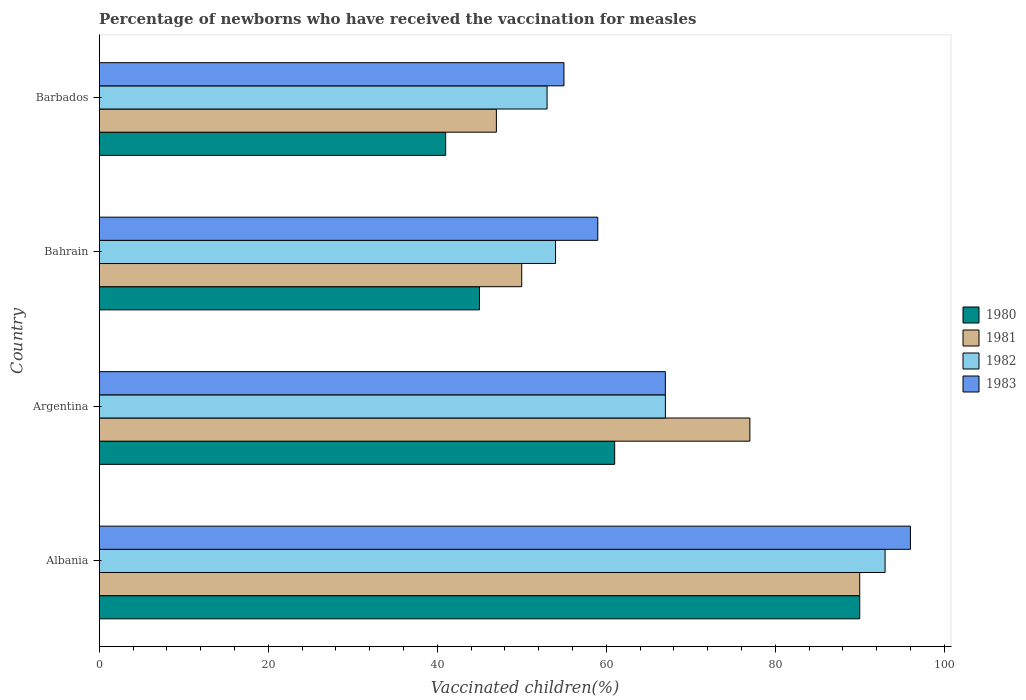How many different coloured bars are there?
Offer a very short reply. 4. Are the number of bars per tick equal to the number of legend labels?
Make the answer very short. Yes. How many bars are there on the 2nd tick from the top?
Provide a short and direct response. 4. How many bars are there on the 3rd tick from the bottom?
Offer a very short reply. 4. What is the label of the 2nd group of bars from the top?
Provide a succinct answer. Bahrain. In how many cases, is the number of bars for a given country not equal to the number of legend labels?
Provide a short and direct response. 0. What is the percentage of vaccinated children in 1983 in Albania?
Your response must be concise. 96. Across all countries, what is the maximum percentage of vaccinated children in 1982?
Your response must be concise. 93. In which country was the percentage of vaccinated children in 1980 maximum?
Give a very brief answer. Albania. In which country was the percentage of vaccinated children in 1980 minimum?
Offer a terse response. Barbados. What is the total percentage of vaccinated children in 1981 in the graph?
Offer a very short reply. 264. What is the difference between the percentage of vaccinated children in 1980 in Argentina and that in Bahrain?
Make the answer very short. 16. What is the difference between the percentage of vaccinated children in 1981 in Albania and the percentage of vaccinated children in 1982 in Bahrain?
Offer a terse response. 36. What is the average percentage of vaccinated children in 1980 per country?
Keep it short and to the point. 59.25. What is the difference between the percentage of vaccinated children in 1982 and percentage of vaccinated children in 1981 in Argentina?
Keep it short and to the point. -10. What is the ratio of the percentage of vaccinated children in 1982 in Albania to that in Argentina?
Keep it short and to the point. 1.39. Is the percentage of vaccinated children in 1981 in Bahrain less than that in Barbados?
Provide a short and direct response. No. Is the difference between the percentage of vaccinated children in 1982 in Albania and Barbados greater than the difference between the percentage of vaccinated children in 1981 in Albania and Barbados?
Make the answer very short. No. What is the difference between the highest and the second highest percentage of vaccinated children in 1981?
Make the answer very short. 13. In how many countries, is the percentage of vaccinated children in 1982 greater than the average percentage of vaccinated children in 1982 taken over all countries?
Give a very brief answer. 2. Is the sum of the percentage of vaccinated children in 1982 in Albania and Barbados greater than the maximum percentage of vaccinated children in 1980 across all countries?
Keep it short and to the point. Yes. What does the 4th bar from the bottom in Bahrain represents?
Your answer should be compact. 1983. Are all the bars in the graph horizontal?
Provide a succinct answer. Yes. How many countries are there in the graph?
Make the answer very short. 4. Does the graph contain any zero values?
Give a very brief answer. No. Where does the legend appear in the graph?
Make the answer very short. Center right. How are the legend labels stacked?
Make the answer very short. Vertical. What is the title of the graph?
Provide a succinct answer. Percentage of newborns who have received the vaccination for measles. Does "2010" appear as one of the legend labels in the graph?
Make the answer very short. No. What is the label or title of the X-axis?
Your response must be concise. Vaccinated children(%). What is the Vaccinated children(%) of 1980 in Albania?
Your response must be concise. 90. What is the Vaccinated children(%) of 1982 in Albania?
Offer a terse response. 93. What is the Vaccinated children(%) in 1983 in Albania?
Provide a short and direct response. 96. What is the Vaccinated children(%) of 1980 in Argentina?
Your answer should be very brief. 61. What is the Vaccinated children(%) of 1981 in Argentina?
Make the answer very short. 77. What is the Vaccinated children(%) in 1982 in Argentina?
Make the answer very short. 67. What is the Vaccinated children(%) of 1983 in Argentina?
Make the answer very short. 67. What is the Vaccinated children(%) in 1981 in Bahrain?
Your answer should be very brief. 50. What is the Vaccinated children(%) in 1980 in Barbados?
Provide a short and direct response. 41. What is the Vaccinated children(%) in 1982 in Barbados?
Offer a terse response. 53. What is the Vaccinated children(%) in 1983 in Barbados?
Your answer should be very brief. 55. Across all countries, what is the maximum Vaccinated children(%) in 1980?
Provide a succinct answer. 90. Across all countries, what is the maximum Vaccinated children(%) of 1981?
Your response must be concise. 90. Across all countries, what is the maximum Vaccinated children(%) in 1982?
Make the answer very short. 93. Across all countries, what is the maximum Vaccinated children(%) in 1983?
Your answer should be compact. 96. What is the total Vaccinated children(%) in 1980 in the graph?
Your answer should be compact. 237. What is the total Vaccinated children(%) in 1981 in the graph?
Your answer should be compact. 264. What is the total Vaccinated children(%) in 1982 in the graph?
Keep it short and to the point. 267. What is the total Vaccinated children(%) of 1983 in the graph?
Make the answer very short. 277. What is the difference between the Vaccinated children(%) of 1981 in Albania and that in Bahrain?
Offer a terse response. 40. What is the difference between the Vaccinated children(%) in 1980 in Albania and that in Barbados?
Make the answer very short. 49. What is the difference between the Vaccinated children(%) in 1980 in Argentina and that in Bahrain?
Your response must be concise. 16. What is the difference between the Vaccinated children(%) in 1982 in Argentina and that in Bahrain?
Ensure brevity in your answer.  13. What is the difference between the Vaccinated children(%) of 1981 in Argentina and that in Barbados?
Provide a short and direct response. 30. What is the difference between the Vaccinated children(%) of 1982 in Argentina and that in Barbados?
Your answer should be compact. 14. What is the difference between the Vaccinated children(%) in 1983 in Argentina and that in Barbados?
Your response must be concise. 12. What is the difference between the Vaccinated children(%) of 1980 in Bahrain and that in Barbados?
Ensure brevity in your answer.  4. What is the difference between the Vaccinated children(%) of 1981 in Bahrain and that in Barbados?
Give a very brief answer. 3. What is the difference between the Vaccinated children(%) of 1980 in Albania and the Vaccinated children(%) of 1983 in Argentina?
Your response must be concise. 23. What is the difference between the Vaccinated children(%) of 1981 in Albania and the Vaccinated children(%) of 1982 in Argentina?
Provide a succinct answer. 23. What is the difference between the Vaccinated children(%) of 1980 in Albania and the Vaccinated children(%) of 1981 in Bahrain?
Ensure brevity in your answer.  40. What is the difference between the Vaccinated children(%) of 1981 in Albania and the Vaccinated children(%) of 1982 in Bahrain?
Offer a terse response. 36. What is the difference between the Vaccinated children(%) of 1982 in Albania and the Vaccinated children(%) of 1983 in Bahrain?
Offer a terse response. 34. What is the difference between the Vaccinated children(%) in 1980 in Albania and the Vaccinated children(%) in 1983 in Barbados?
Give a very brief answer. 35. What is the difference between the Vaccinated children(%) in 1981 in Albania and the Vaccinated children(%) in 1982 in Barbados?
Keep it short and to the point. 37. What is the difference between the Vaccinated children(%) in 1982 in Albania and the Vaccinated children(%) in 1983 in Barbados?
Your answer should be very brief. 38. What is the difference between the Vaccinated children(%) of 1982 in Argentina and the Vaccinated children(%) of 1983 in Bahrain?
Keep it short and to the point. 8. What is the difference between the Vaccinated children(%) in 1980 in Argentina and the Vaccinated children(%) in 1982 in Barbados?
Give a very brief answer. 8. What is the difference between the Vaccinated children(%) of 1981 in Argentina and the Vaccinated children(%) of 1982 in Barbados?
Offer a very short reply. 24. What is the difference between the Vaccinated children(%) in 1981 in Argentina and the Vaccinated children(%) in 1983 in Barbados?
Keep it short and to the point. 22. What is the difference between the Vaccinated children(%) in 1982 in Argentina and the Vaccinated children(%) in 1983 in Barbados?
Provide a succinct answer. 12. What is the difference between the Vaccinated children(%) of 1980 in Bahrain and the Vaccinated children(%) of 1982 in Barbados?
Offer a terse response. -8. What is the difference between the Vaccinated children(%) of 1980 in Bahrain and the Vaccinated children(%) of 1983 in Barbados?
Make the answer very short. -10. What is the difference between the Vaccinated children(%) in 1982 in Bahrain and the Vaccinated children(%) in 1983 in Barbados?
Offer a terse response. -1. What is the average Vaccinated children(%) in 1980 per country?
Provide a succinct answer. 59.25. What is the average Vaccinated children(%) in 1981 per country?
Make the answer very short. 66. What is the average Vaccinated children(%) of 1982 per country?
Your response must be concise. 66.75. What is the average Vaccinated children(%) in 1983 per country?
Offer a very short reply. 69.25. What is the difference between the Vaccinated children(%) in 1981 and Vaccinated children(%) in 1982 in Albania?
Your response must be concise. -3. What is the difference between the Vaccinated children(%) of 1981 and Vaccinated children(%) of 1983 in Albania?
Give a very brief answer. -6. What is the difference between the Vaccinated children(%) of 1980 and Vaccinated children(%) of 1981 in Argentina?
Offer a very short reply. -16. What is the difference between the Vaccinated children(%) in 1980 and Vaccinated children(%) in 1983 in Bahrain?
Ensure brevity in your answer.  -14. What is the difference between the Vaccinated children(%) in 1981 and Vaccinated children(%) in 1982 in Bahrain?
Give a very brief answer. -4. What is the difference between the Vaccinated children(%) of 1980 and Vaccinated children(%) of 1983 in Barbados?
Give a very brief answer. -14. What is the difference between the Vaccinated children(%) of 1981 and Vaccinated children(%) of 1983 in Barbados?
Offer a very short reply. -8. What is the ratio of the Vaccinated children(%) of 1980 in Albania to that in Argentina?
Offer a terse response. 1.48. What is the ratio of the Vaccinated children(%) in 1981 in Albania to that in Argentina?
Keep it short and to the point. 1.17. What is the ratio of the Vaccinated children(%) of 1982 in Albania to that in Argentina?
Offer a terse response. 1.39. What is the ratio of the Vaccinated children(%) of 1983 in Albania to that in Argentina?
Offer a very short reply. 1.43. What is the ratio of the Vaccinated children(%) of 1980 in Albania to that in Bahrain?
Ensure brevity in your answer.  2. What is the ratio of the Vaccinated children(%) of 1982 in Albania to that in Bahrain?
Make the answer very short. 1.72. What is the ratio of the Vaccinated children(%) of 1983 in Albania to that in Bahrain?
Provide a succinct answer. 1.63. What is the ratio of the Vaccinated children(%) in 1980 in Albania to that in Barbados?
Make the answer very short. 2.2. What is the ratio of the Vaccinated children(%) of 1981 in Albania to that in Barbados?
Your response must be concise. 1.91. What is the ratio of the Vaccinated children(%) in 1982 in Albania to that in Barbados?
Ensure brevity in your answer.  1.75. What is the ratio of the Vaccinated children(%) in 1983 in Albania to that in Barbados?
Give a very brief answer. 1.75. What is the ratio of the Vaccinated children(%) of 1980 in Argentina to that in Bahrain?
Your answer should be very brief. 1.36. What is the ratio of the Vaccinated children(%) of 1981 in Argentina to that in Bahrain?
Your response must be concise. 1.54. What is the ratio of the Vaccinated children(%) in 1982 in Argentina to that in Bahrain?
Ensure brevity in your answer.  1.24. What is the ratio of the Vaccinated children(%) of 1983 in Argentina to that in Bahrain?
Ensure brevity in your answer.  1.14. What is the ratio of the Vaccinated children(%) of 1980 in Argentina to that in Barbados?
Offer a terse response. 1.49. What is the ratio of the Vaccinated children(%) of 1981 in Argentina to that in Barbados?
Your answer should be compact. 1.64. What is the ratio of the Vaccinated children(%) in 1982 in Argentina to that in Barbados?
Your answer should be compact. 1.26. What is the ratio of the Vaccinated children(%) of 1983 in Argentina to that in Barbados?
Give a very brief answer. 1.22. What is the ratio of the Vaccinated children(%) of 1980 in Bahrain to that in Barbados?
Give a very brief answer. 1.1. What is the ratio of the Vaccinated children(%) in 1981 in Bahrain to that in Barbados?
Keep it short and to the point. 1.06. What is the ratio of the Vaccinated children(%) of 1982 in Bahrain to that in Barbados?
Make the answer very short. 1.02. What is the ratio of the Vaccinated children(%) in 1983 in Bahrain to that in Barbados?
Make the answer very short. 1.07. What is the difference between the highest and the second highest Vaccinated children(%) of 1980?
Give a very brief answer. 29. What is the difference between the highest and the second highest Vaccinated children(%) in 1983?
Your answer should be very brief. 29. What is the difference between the highest and the lowest Vaccinated children(%) in 1980?
Provide a short and direct response. 49. What is the difference between the highest and the lowest Vaccinated children(%) in 1982?
Your answer should be compact. 40. What is the difference between the highest and the lowest Vaccinated children(%) in 1983?
Offer a terse response. 41. 